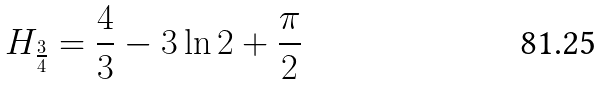Convert formula to latex. <formula><loc_0><loc_0><loc_500><loc_500>H _ { \frac { 3 } { 4 } } = { \frac { 4 } { 3 } } - 3 \ln { 2 } + { \frac { \pi } { 2 } }</formula> 